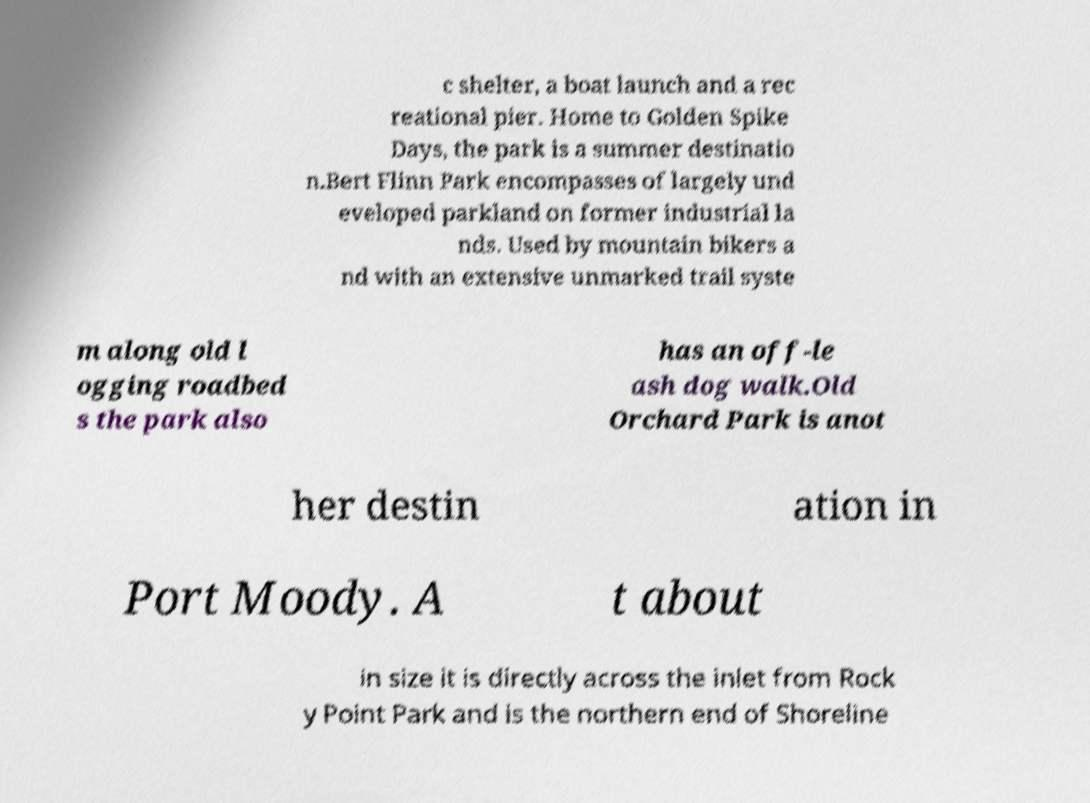Could you extract and type out the text from this image? c shelter, a boat launch and a rec reational pier. Home to Golden Spike Days, the park is a summer destinatio n.Bert Flinn Park encompasses of largely und eveloped parkland on former industrial la nds. Used by mountain bikers a nd with an extensive unmarked trail syste m along old l ogging roadbed s the park also has an off-le ash dog walk.Old Orchard Park is anot her destin ation in Port Moody. A t about in size it is directly across the inlet from Rock y Point Park and is the northern end of Shoreline 